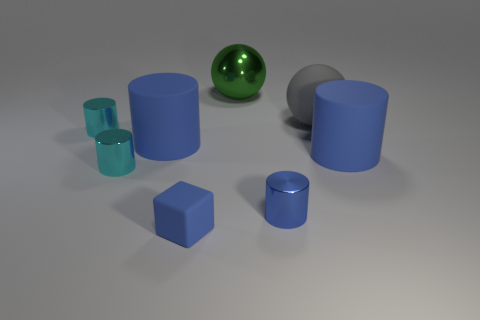Subtract all brown spheres. How many blue cylinders are left? 3 Subtract all blue metal cylinders. How many cylinders are left? 4 Add 1 gray rubber spheres. How many objects exist? 9 Subtract all yellow cylinders. Subtract all brown blocks. How many cylinders are left? 5 Subtract all cylinders. How many objects are left? 3 Subtract 1 gray spheres. How many objects are left? 7 Subtract all metallic cylinders. Subtract all big matte cylinders. How many objects are left? 3 Add 7 matte balls. How many matte balls are left? 8 Add 6 cyan cylinders. How many cyan cylinders exist? 8 